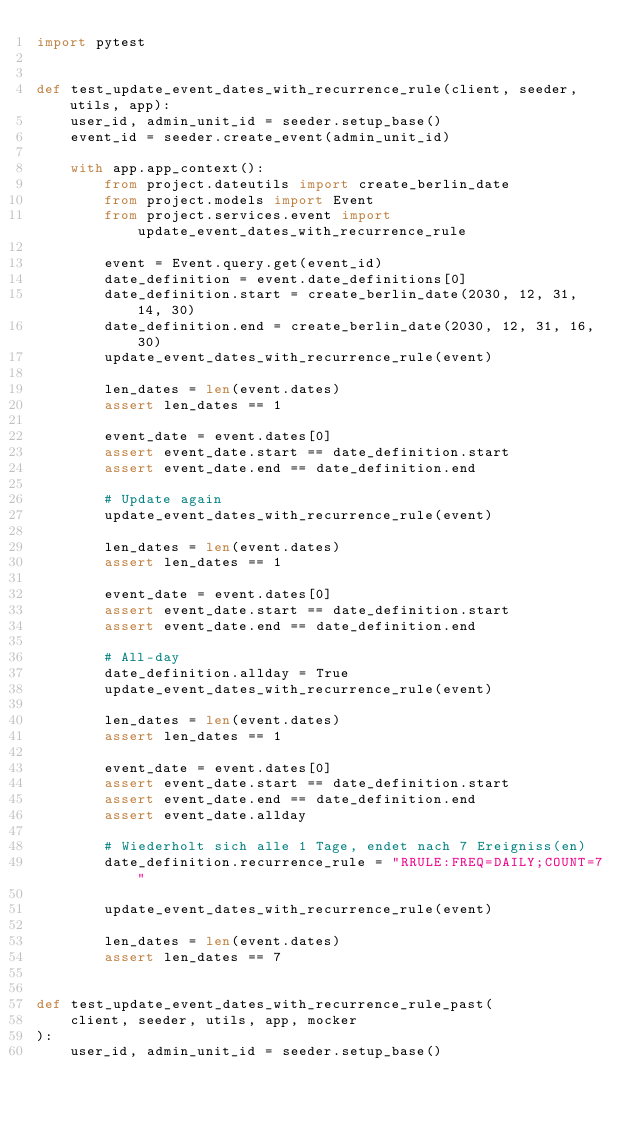Convert code to text. <code><loc_0><loc_0><loc_500><loc_500><_Python_>import pytest


def test_update_event_dates_with_recurrence_rule(client, seeder, utils, app):
    user_id, admin_unit_id = seeder.setup_base()
    event_id = seeder.create_event(admin_unit_id)

    with app.app_context():
        from project.dateutils import create_berlin_date
        from project.models import Event
        from project.services.event import update_event_dates_with_recurrence_rule

        event = Event.query.get(event_id)
        date_definition = event.date_definitions[0]
        date_definition.start = create_berlin_date(2030, 12, 31, 14, 30)
        date_definition.end = create_berlin_date(2030, 12, 31, 16, 30)
        update_event_dates_with_recurrence_rule(event)

        len_dates = len(event.dates)
        assert len_dates == 1

        event_date = event.dates[0]
        assert event_date.start == date_definition.start
        assert event_date.end == date_definition.end

        # Update again
        update_event_dates_with_recurrence_rule(event)

        len_dates = len(event.dates)
        assert len_dates == 1

        event_date = event.dates[0]
        assert event_date.start == date_definition.start
        assert event_date.end == date_definition.end

        # All-day
        date_definition.allday = True
        update_event_dates_with_recurrence_rule(event)

        len_dates = len(event.dates)
        assert len_dates == 1

        event_date = event.dates[0]
        assert event_date.start == date_definition.start
        assert event_date.end == date_definition.end
        assert event_date.allday

        # Wiederholt sich alle 1 Tage, endet nach 7 Ereigniss(en)
        date_definition.recurrence_rule = "RRULE:FREQ=DAILY;COUNT=7"

        update_event_dates_with_recurrence_rule(event)

        len_dates = len(event.dates)
        assert len_dates == 7


def test_update_event_dates_with_recurrence_rule_past(
    client, seeder, utils, app, mocker
):
    user_id, admin_unit_id = seeder.setup_base()</code> 